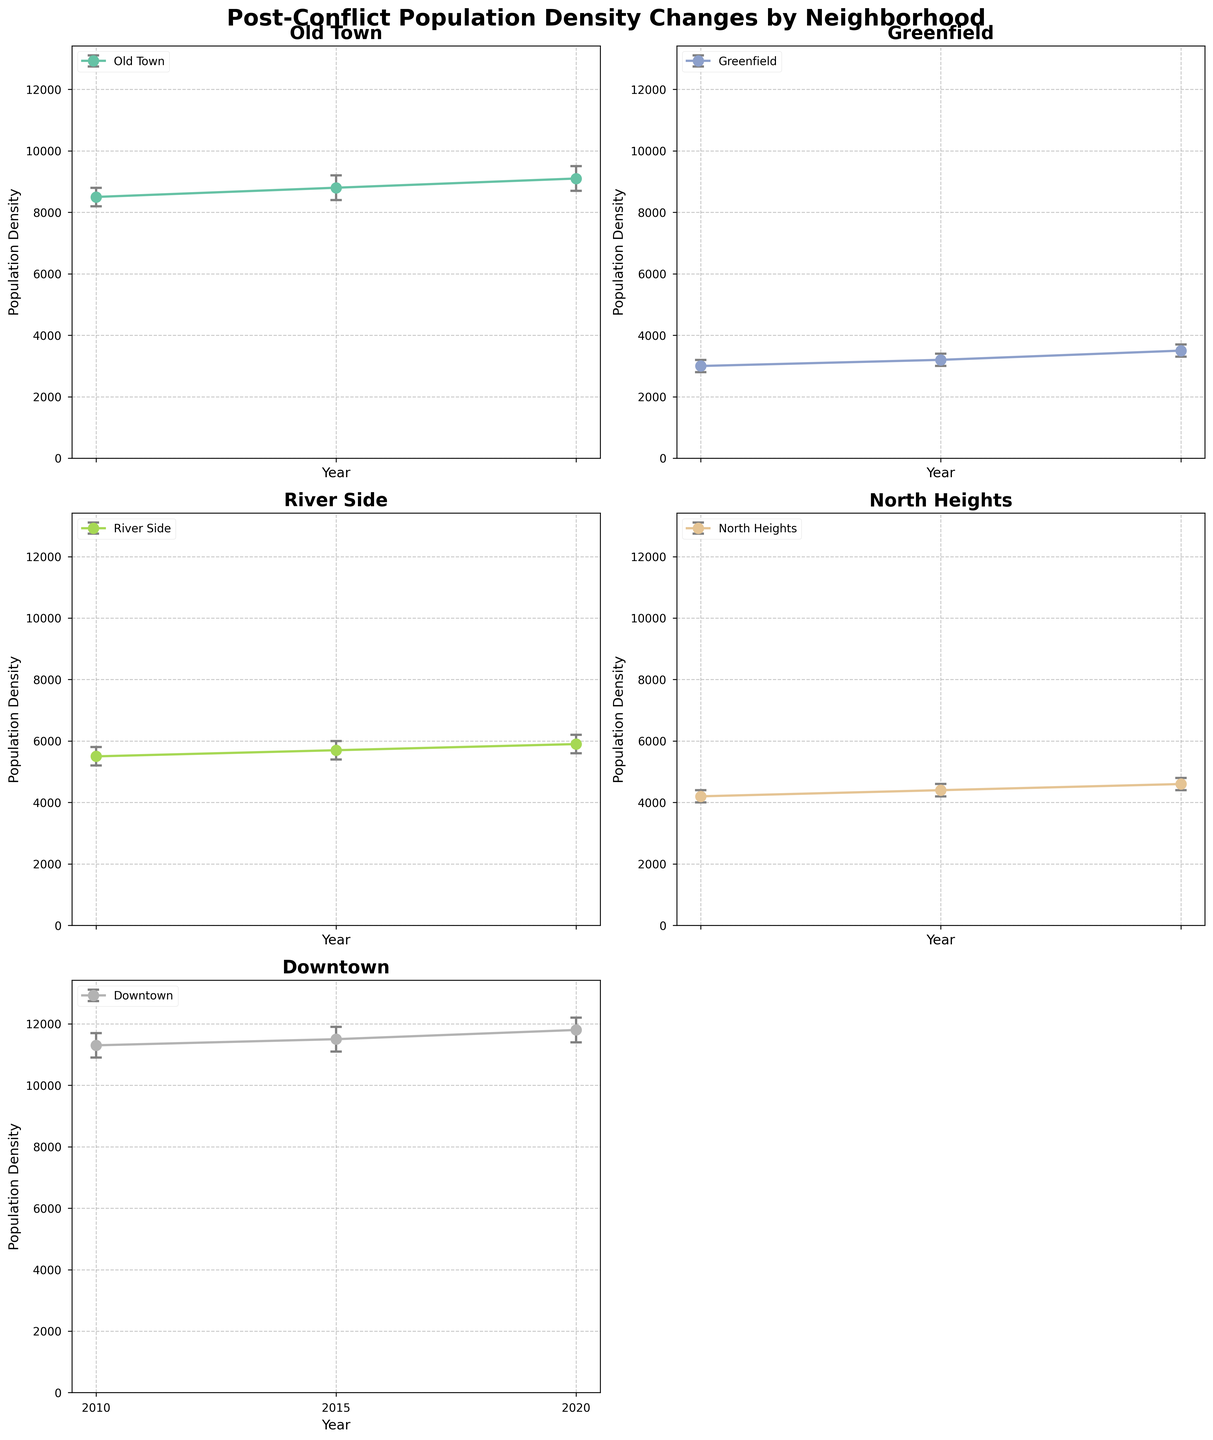What is the title of the figure? The title of the figure is displayed at the top and describes the main content and purpose of the figure. In this case, it is "Post-Conflict Population Density Changes by Neighborhood".
Answer: Post-Conflict Population Density Changes by Neighborhood Which neighborhood had the highest population density in 2020? By examining the population density data points of 2020 for each neighborhood, we find that Downtown has the highest population density.
Answer: Downtown What is the difference in population density between Old Town and Greenfield in 2020? By looking at the 2020 population densities for Old Town (9100) and Greenfield (3500), we find the difference by subtracting the values: 9100 - 3500 = 5600.
Answer: 5600 Which neighborhood shows the most consistent population density growth from 2010 to 2020? A consistent growth would mean seeing a steady increase in population density over time without large fluctuations. By visually examining each subplot, we notice that Downtown shows a steady and consistent increase from 11300 in 2010 to 11800 in 2020.
Answer: Downtown Compare the confidence interval width for Greenfield in 2010 and 2020. Which year shows a narrower interval? To compare the widths, we look at the difference between UpperCI and LowerCI for each year: In 2010, it is 3200 - 2800 = 400; in 2020, it is 3700 - 3300 = 400. The widths are equal.
Answer: Both are equal What was the population density of River Side in 2015, and what are the lower and upper bounds of its confidence interval? To find these, we look at the 2015 data for River Side, where the population density is 5700, the lower bound is at 5400, and the upper bound is at 6000.
Answer: 5700, 5400, 6000 Which neighborhood had the smallest population density in 2010? By comparing the 2010 population densities of all neighborhoods, Greenfield has the smallest population density of 3000.
Answer: Greenfield For North Heights, what is the average population density over the three years presented? To calculate the average: (4200 in 2010 + 4400 in 2015 + 4600 in 2020) / 3 = 13200 / 3 = 4400.
Answer: 4400 How does the population density change in Old Town from 2010 to 2020? By tracking the population density in Old Town across the years: starting from 8500 in 2010, increasing to 8800 in 2015, and further increasing to 9100 in 2020. The change is steady growth.
Answer: Steady growth Between the neighborhoods presented, which shows the smallest confidence interval in any given year and what is that interval? By comparing the confidence intervals across all neighborhoods and years, Greenfield in 2010 and 2020 has the smallest interval with a width of 400 (3200 - 2800 in 2010 and 3700 - 3300 in 2020).
Answer: Greenfield, 400 